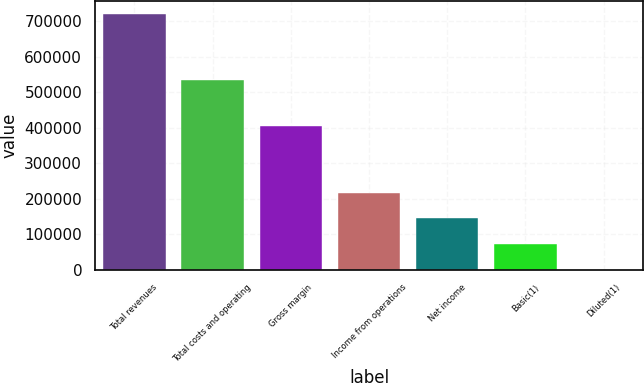<chart> <loc_0><loc_0><loc_500><loc_500><bar_chart><fcel>Total revenues<fcel>Total costs and operating<fcel>Gross margin<fcel>Income from operations<fcel>Net income<fcel>Basic(1)<fcel>Diluted(1)<nl><fcel>720709<fcel>534152<fcel>403484<fcel>216213<fcel>144142<fcel>72071.6<fcel>0.8<nl></chart> 